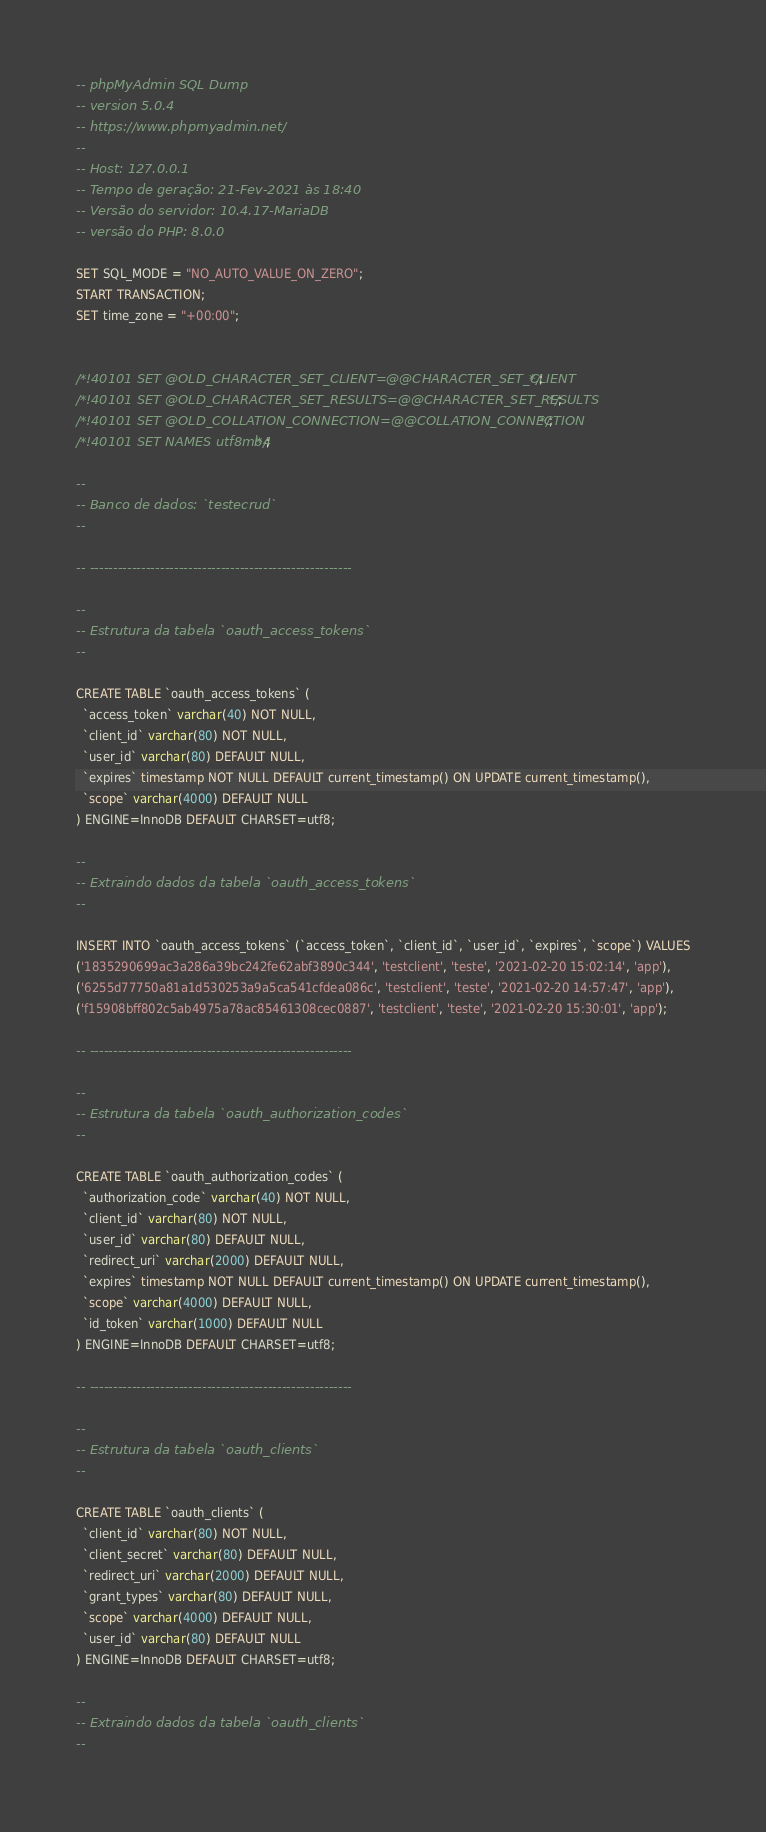<code> <loc_0><loc_0><loc_500><loc_500><_SQL_>-- phpMyAdmin SQL Dump
-- version 5.0.4
-- https://www.phpmyadmin.net/
--
-- Host: 127.0.0.1
-- Tempo de geração: 21-Fev-2021 às 18:40
-- Versão do servidor: 10.4.17-MariaDB
-- versão do PHP: 8.0.0

SET SQL_MODE = "NO_AUTO_VALUE_ON_ZERO";
START TRANSACTION;
SET time_zone = "+00:00";


/*!40101 SET @OLD_CHARACTER_SET_CLIENT=@@CHARACTER_SET_CLIENT */;
/*!40101 SET @OLD_CHARACTER_SET_RESULTS=@@CHARACTER_SET_RESULTS */;
/*!40101 SET @OLD_COLLATION_CONNECTION=@@COLLATION_CONNECTION */;
/*!40101 SET NAMES utf8mb4 */;

--
-- Banco de dados: `testecrud`
--

-- --------------------------------------------------------

--
-- Estrutura da tabela `oauth_access_tokens`
--

CREATE TABLE `oauth_access_tokens` (
  `access_token` varchar(40) NOT NULL,
  `client_id` varchar(80) NOT NULL,
  `user_id` varchar(80) DEFAULT NULL,
  `expires` timestamp NOT NULL DEFAULT current_timestamp() ON UPDATE current_timestamp(),
  `scope` varchar(4000) DEFAULT NULL
) ENGINE=InnoDB DEFAULT CHARSET=utf8;

--
-- Extraindo dados da tabela `oauth_access_tokens`
--

INSERT INTO `oauth_access_tokens` (`access_token`, `client_id`, `user_id`, `expires`, `scope`) VALUES
('1835290699ac3a286a39bc242fe62abf3890c344', 'testclient', 'teste', '2021-02-20 15:02:14', 'app'),
('6255d77750a81a1d530253a9a5ca541cfdea086c', 'testclient', 'teste', '2021-02-20 14:57:47', 'app'),
('f15908bff802c5ab4975a78ac85461308cec0887', 'testclient', 'teste', '2021-02-20 15:30:01', 'app');

-- --------------------------------------------------------

--
-- Estrutura da tabela `oauth_authorization_codes`
--

CREATE TABLE `oauth_authorization_codes` (
  `authorization_code` varchar(40) NOT NULL,
  `client_id` varchar(80) NOT NULL,
  `user_id` varchar(80) DEFAULT NULL,
  `redirect_uri` varchar(2000) DEFAULT NULL,
  `expires` timestamp NOT NULL DEFAULT current_timestamp() ON UPDATE current_timestamp(),
  `scope` varchar(4000) DEFAULT NULL,
  `id_token` varchar(1000) DEFAULT NULL
) ENGINE=InnoDB DEFAULT CHARSET=utf8;

-- --------------------------------------------------------

--
-- Estrutura da tabela `oauth_clients`
--

CREATE TABLE `oauth_clients` (
  `client_id` varchar(80) NOT NULL,
  `client_secret` varchar(80) DEFAULT NULL,
  `redirect_uri` varchar(2000) DEFAULT NULL,
  `grant_types` varchar(80) DEFAULT NULL,
  `scope` varchar(4000) DEFAULT NULL,
  `user_id` varchar(80) DEFAULT NULL
) ENGINE=InnoDB DEFAULT CHARSET=utf8;

--
-- Extraindo dados da tabela `oauth_clients`
--
</code> 